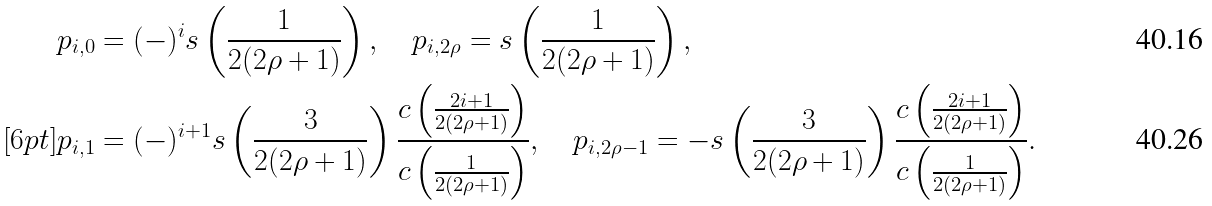<formula> <loc_0><loc_0><loc_500><loc_500>& p _ { i , 0 } = ( - ) ^ { i } s \left ( \frac { 1 } { 2 ( 2 \rho + 1 ) } \right ) , \quad p _ { i , 2 \rho } = s \left ( \frac { 1 } { 2 ( 2 \rho + 1 ) } \right ) , \\ [ 6 p t ] & p _ { i , 1 } = ( - ) ^ { i + 1 } s \left ( \frac { 3 } { 2 ( 2 \rho + 1 ) } \right ) \frac { c \left ( \frac { 2 i + 1 } { 2 ( 2 \rho + 1 ) } \right ) } { c \left ( \frac { 1 } { 2 ( 2 \rho + 1 ) } \right ) } , \quad p _ { i , 2 \rho - 1 } = - s \left ( \frac { 3 } { 2 ( 2 \rho + 1 ) } \right ) \frac { c \left ( \frac { 2 i + 1 } { 2 ( 2 \rho + 1 ) } \right ) } { c \left ( \frac { 1 } { 2 ( 2 \rho + 1 ) } \right ) } .</formula> 